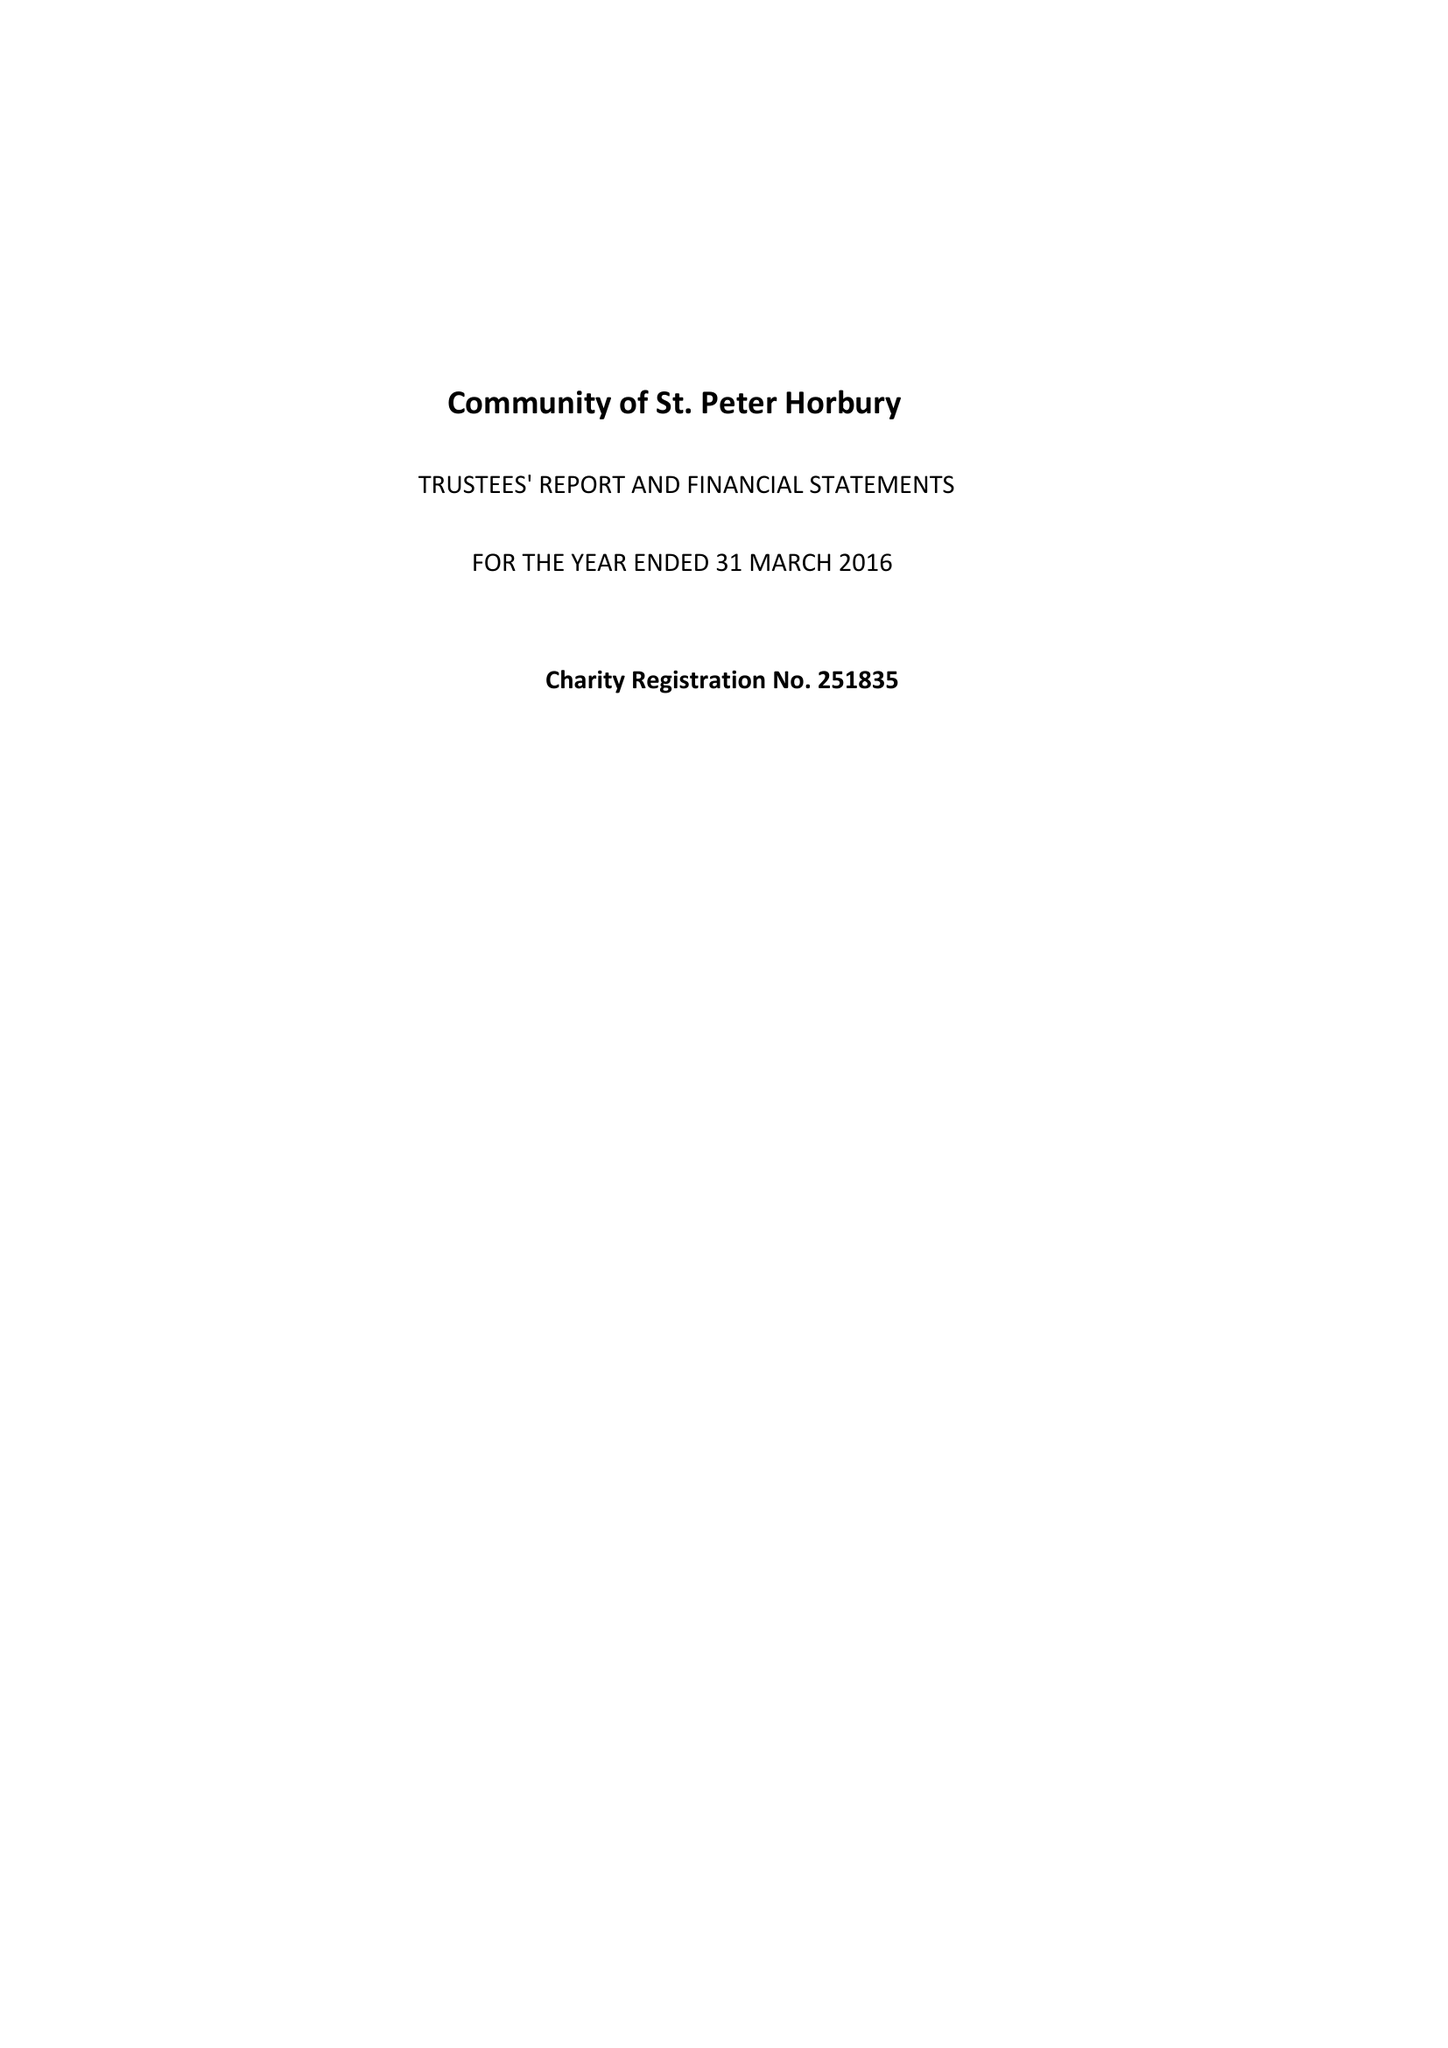What is the value for the report_date?
Answer the question using a single word or phrase. 2016-03-31 